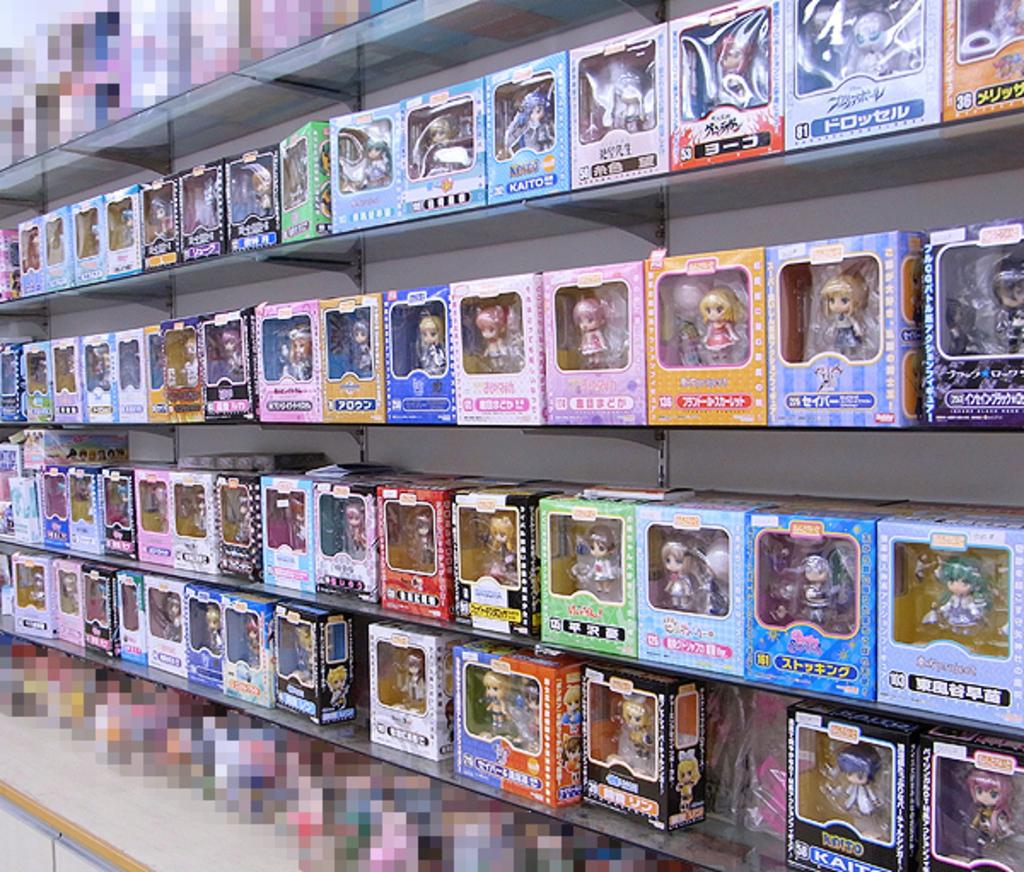What language is the text on the boxes?
Ensure brevity in your answer.  Japanese. 